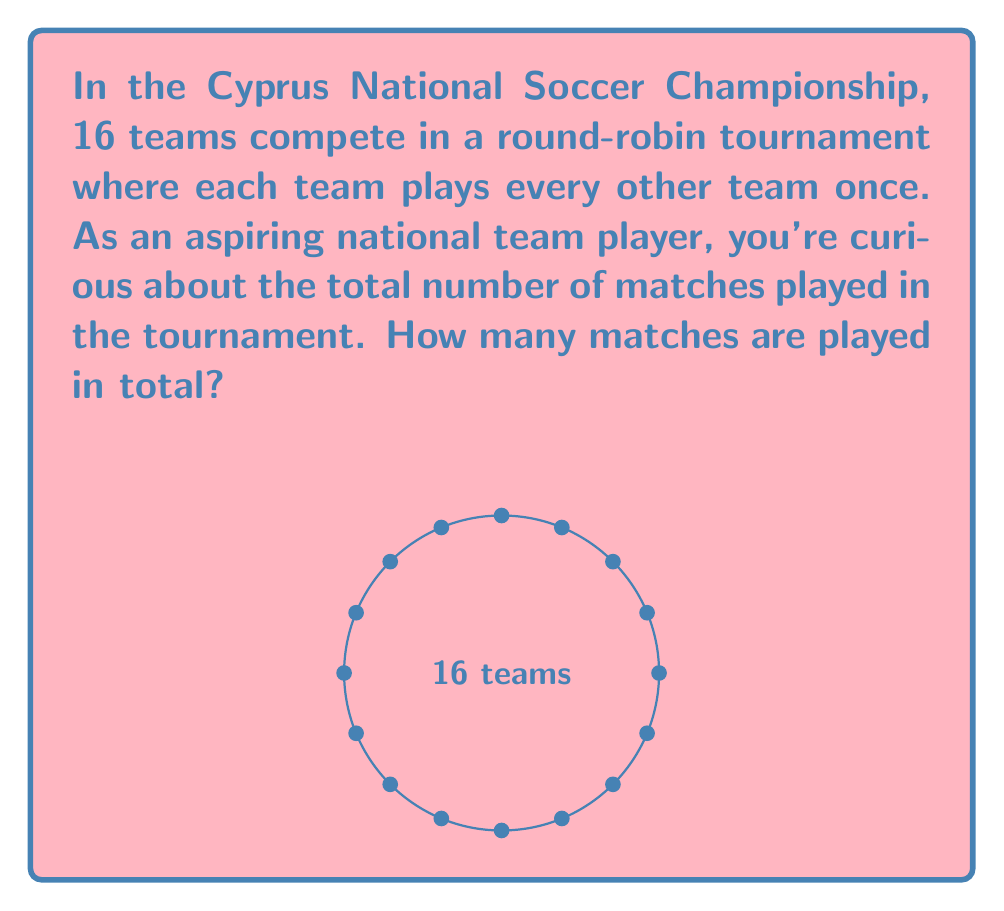Give your solution to this math problem. Let's approach this step-by-step:

1) In a round-robin tournament, each team plays every other team once.

2) To find the total number of matches, we need to calculate how many unique pairs of teams can be formed.

3) This is a combination problem. We're selecting 2 teams from 16 teams, where the order doesn't matter (Team A vs Team B is the same as Team B vs Team A).

4) The formula for combinations is:

   $$C(n,r) = \frac{n!}{r!(n-r)!}$$

   where $n$ is the total number of items to choose from, and $r$ is the number of items being chosen.

5) In this case, $n = 16$ (total teams) and $r = 2$ (we're choosing 2 teams for each match).

6) Plugging into the formula:

   $$C(16,2) = \frac{16!}{2!(16-2)!} = \frac{16!}{2!(14)!}$$

7) Simplifying:
   
   $$\frac{16 \cdot 15 \cdot 14!}{2 \cdot 1 \cdot 14!} = \frac{16 \cdot 15}{2} = \frac{240}{2} = 120$$

Therefore, there will be 120 matches played in total.
Answer: 120 matches 